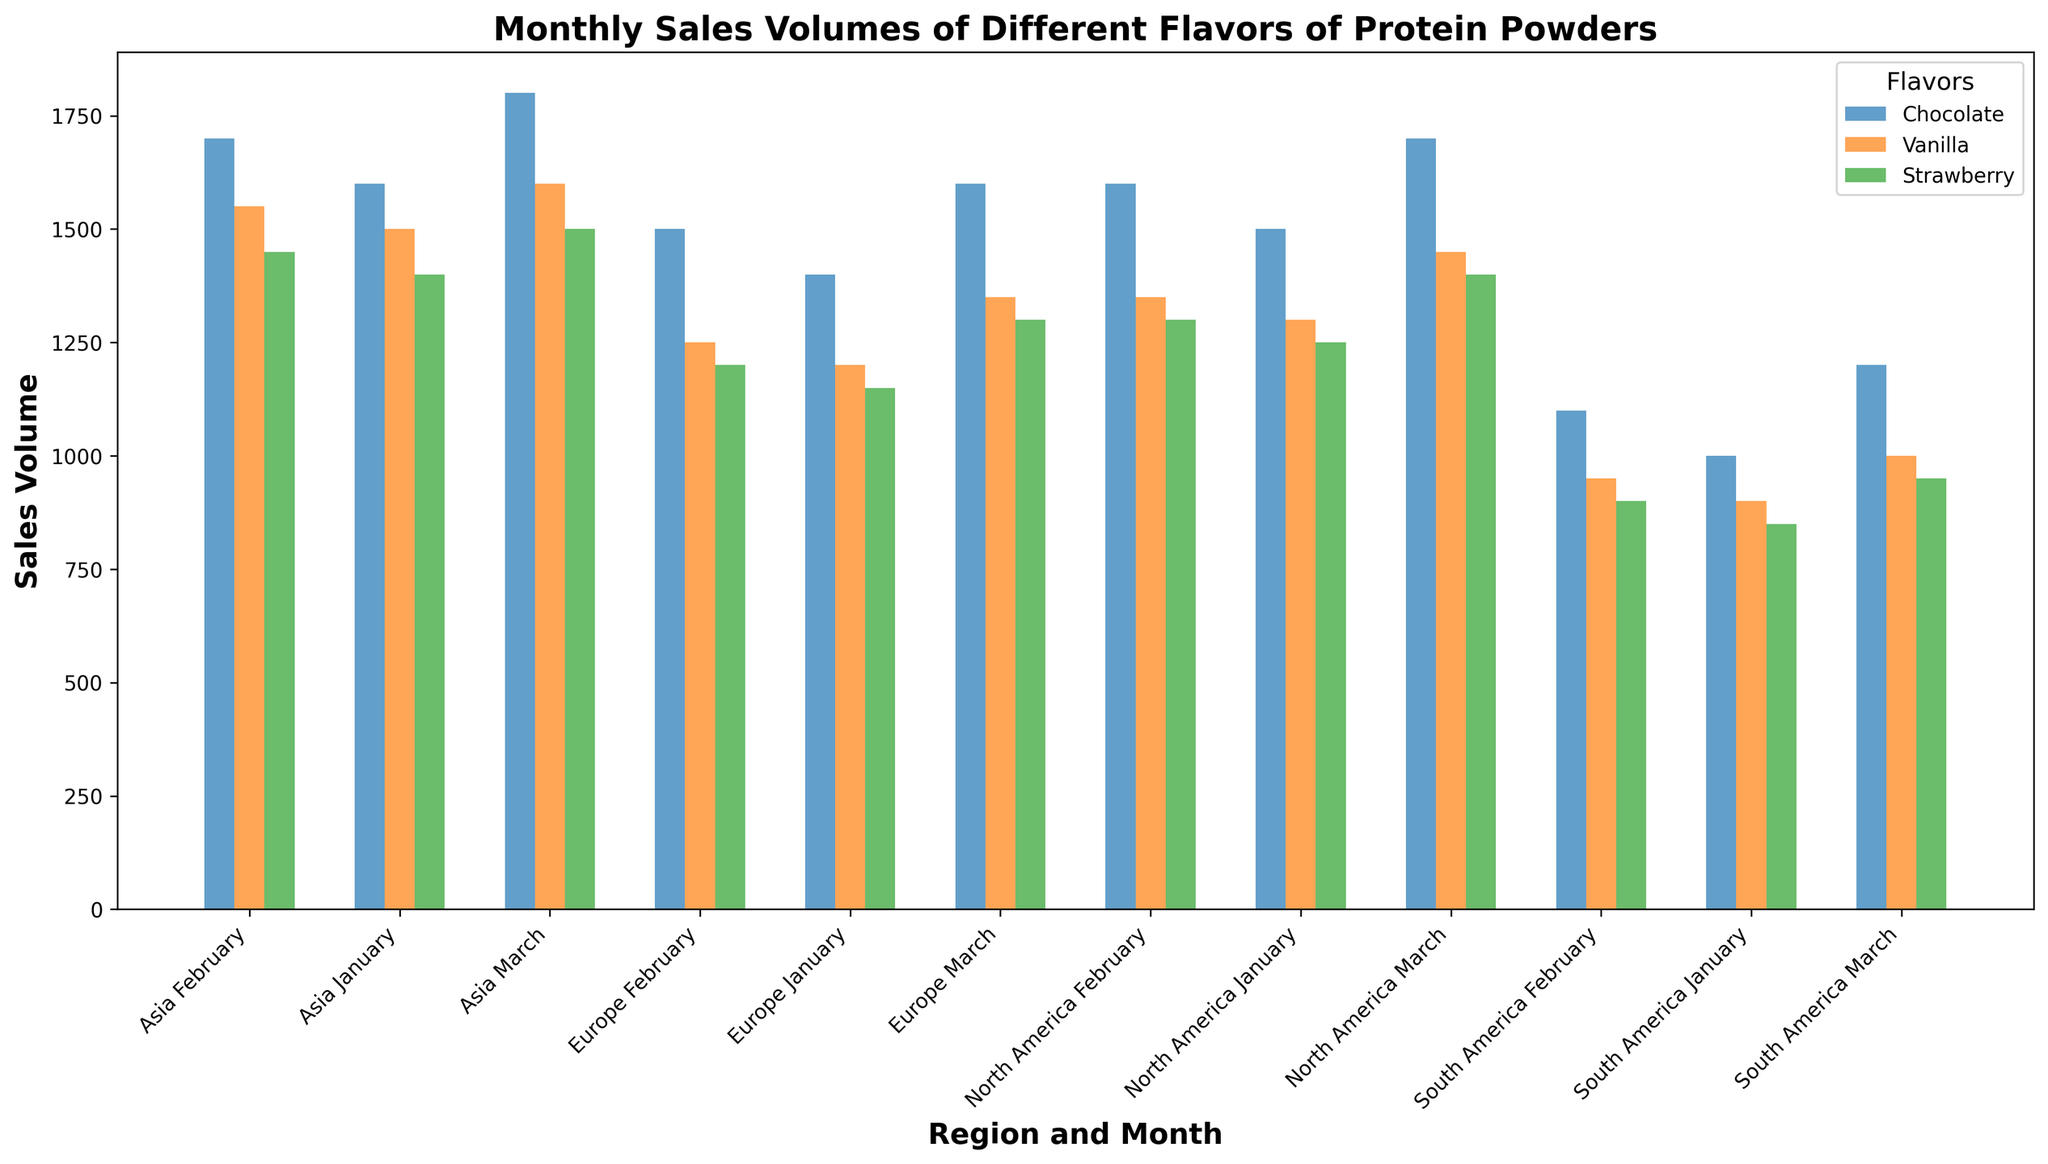Which region had the highest sales volume for Chocolate flavor in March? To answer this, locate the bars representing Chocolate flavor for each region and compare their heights for the month of March. The highest bar among these will indicate the region with the highest sales.
Answer: Asia What is the total sales volume for all flavors combined in North America in January? Sum up the sales volumes for Chocolate, Vanilla, and Strawberry flavors in North America for the month of January. The individual volumes are 1500 (Chocolate), 1300 (Vanilla), and 1250 (Strawberry). Adding these together gives 4050.
Answer: 4050 Which flavor had the smallest difference in sales volumes between February and March in South America? Calculate the difference in sales volumes between February and March for each flavor in South America. For Chocolate: 1200 - 1100 = 100, Vanilla: 1000 - 950 = 50, and Strawberry: 950 - 900 = 50. The smallest difference is shared by Vanilla and Strawberry.
Answer: Vanilla and Strawberry In which region did Vanilla flavor sales increase the most from January to March? Calculate the increase in sales volume for Vanilla flavor from January to March for each region. North America: 1450 - 1300 = 150, Europe: 1350 - 1200 = 150, Asia: 1600 - 1500 = 100, and South America: 1000 - 900 = 100. North America and Europe had the highest increase of 150 units.
Answer: North America and Europe Compare the sales volumes of all flavors combined in Europe and Asia for February. Which region had higher sales? Sum up the sales volumes for Chocolate, Vanilla, and Strawberry flavors in both Europe and Asia for February. Europe: 1500 (Chocolate) + 1250 (Vanilla) + 1200 (Strawberry) = 3950, Asia: 1700 (Chocolate) + 1550 (Vanilla) + 1450 (Strawberry) = 4700. Asia had higher sales.
Answer: Asia Which flavor showed the least variation in sales volumes across all months in all regions? Calculate the range (difference between maximum and minimum values) of sales volumes for each flavor across all months and regions. Chocolate: 1800 - 1000 = 800, Vanilla: 1600 - 900 = 700, Strawberry: 1500 - 850 = 650. Strawberry showed the least variation with a range of 650.
Answer: Strawberry What was the sales volume of Vanilla flavor in Asia in February? Locate the bar representing Vanilla flavor in Asia for February and read its height or value. The sales volume for Vanilla flavor in February in Asia is 1550.
Answer: 1550 